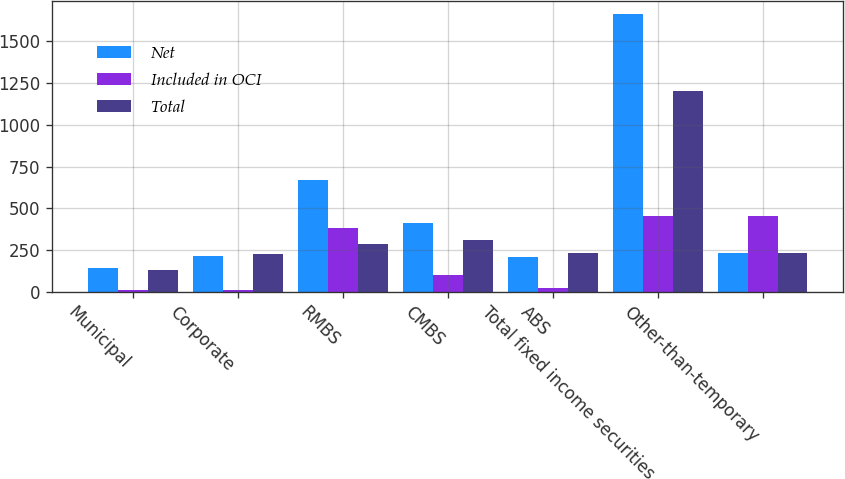Convert chart to OTSL. <chart><loc_0><loc_0><loc_500><loc_500><stacked_bar_chart><ecel><fcel>Municipal<fcel>Corporate<fcel>RMBS<fcel>CMBS<fcel>ABS<fcel>Total fixed income securities<fcel>Other-than-temporary<nl><fcel>Net<fcel>140<fcel>213<fcel>672<fcel>411<fcel>208<fcel>1661<fcel>234<nl><fcel>Included in OCI<fcel>10<fcel>13<fcel>384<fcel>102<fcel>26<fcel>457<fcel>457<nl><fcel>Total<fcel>130<fcel>226<fcel>288<fcel>309<fcel>234<fcel>1204<fcel>234<nl></chart> 